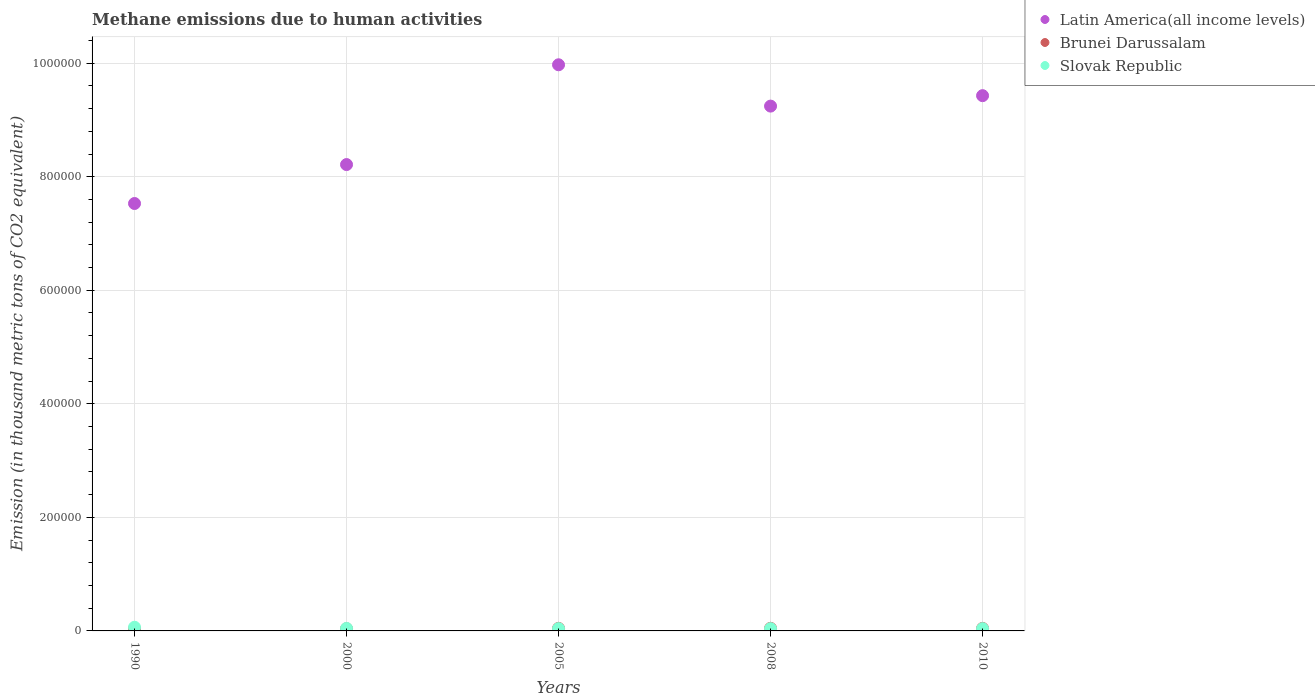How many different coloured dotlines are there?
Your response must be concise. 3. What is the amount of methane emitted in Brunei Darussalam in 2010?
Your response must be concise. 4450.4. Across all years, what is the maximum amount of methane emitted in Latin America(all income levels)?
Provide a short and direct response. 9.97e+05. Across all years, what is the minimum amount of methane emitted in Slovak Republic?
Your answer should be very brief. 3984.7. In which year was the amount of methane emitted in Brunei Darussalam maximum?
Ensure brevity in your answer.  2008. In which year was the amount of methane emitted in Brunei Darussalam minimum?
Give a very brief answer. 1990. What is the total amount of methane emitted in Slovak Republic in the graph?
Your answer should be very brief. 2.29e+04. What is the difference between the amount of methane emitted in Brunei Darussalam in 2005 and that in 2010?
Provide a succinct answer. 92.9. What is the difference between the amount of methane emitted in Latin America(all income levels) in 2000 and the amount of methane emitted in Brunei Darussalam in 2010?
Provide a short and direct response. 8.17e+05. What is the average amount of methane emitted in Brunei Darussalam per year?
Make the answer very short. 4212.1. In the year 2010, what is the difference between the amount of methane emitted in Brunei Darussalam and amount of methane emitted in Slovak Republic?
Offer a terse response. 465.7. In how many years, is the amount of methane emitted in Latin America(all income levels) greater than 720000 thousand metric tons?
Your answer should be compact. 5. What is the ratio of the amount of methane emitted in Brunei Darussalam in 2005 to that in 2008?
Make the answer very short. 0.98. Is the amount of methane emitted in Brunei Darussalam in 1990 less than that in 2010?
Your response must be concise. Yes. What is the difference between the highest and the second highest amount of methane emitted in Slovak Republic?
Ensure brevity in your answer.  2019.1. What is the difference between the highest and the lowest amount of methane emitted in Slovak Republic?
Your answer should be very brief. 2466.7. In how many years, is the amount of methane emitted in Slovak Republic greater than the average amount of methane emitted in Slovak Republic taken over all years?
Offer a terse response. 1. Is the amount of methane emitted in Slovak Republic strictly greater than the amount of methane emitted in Brunei Darussalam over the years?
Provide a short and direct response. No. Is the amount of methane emitted in Brunei Darussalam strictly less than the amount of methane emitted in Slovak Republic over the years?
Provide a succinct answer. No. How many dotlines are there?
Ensure brevity in your answer.  3. What is the difference between two consecutive major ticks on the Y-axis?
Give a very brief answer. 2.00e+05. Where does the legend appear in the graph?
Your answer should be compact. Top right. How many legend labels are there?
Make the answer very short. 3. How are the legend labels stacked?
Make the answer very short. Vertical. What is the title of the graph?
Make the answer very short. Methane emissions due to human activities. Does "Azerbaijan" appear as one of the legend labels in the graph?
Provide a short and direct response. No. What is the label or title of the X-axis?
Provide a short and direct response. Years. What is the label or title of the Y-axis?
Your answer should be very brief. Emission (in thousand metric tons of CO2 equivalent). What is the Emission (in thousand metric tons of CO2 equivalent) of Latin America(all income levels) in 1990?
Ensure brevity in your answer.  7.53e+05. What is the Emission (in thousand metric tons of CO2 equivalent) in Brunei Darussalam in 1990?
Offer a very short reply. 3591.9. What is the Emission (in thousand metric tons of CO2 equivalent) in Slovak Republic in 1990?
Offer a very short reply. 6451.4. What is the Emission (in thousand metric tons of CO2 equivalent) in Latin America(all income levels) in 2000?
Provide a succinct answer. 8.21e+05. What is the Emission (in thousand metric tons of CO2 equivalent) of Brunei Darussalam in 2000?
Keep it short and to the point. 3857.8. What is the Emission (in thousand metric tons of CO2 equivalent) of Slovak Republic in 2000?
Your answer should be compact. 4432.3. What is the Emission (in thousand metric tons of CO2 equivalent) of Latin America(all income levels) in 2005?
Ensure brevity in your answer.  9.97e+05. What is the Emission (in thousand metric tons of CO2 equivalent) in Brunei Darussalam in 2005?
Make the answer very short. 4543.3. What is the Emission (in thousand metric tons of CO2 equivalent) in Slovak Republic in 2005?
Provide a succinct answer. 4063.5. What is the Emission (in thousand metric tons of CO2 equivalent) in Latin America(all income levels) in 2008?
Keep it short and to the point. 9.24e+05. What is the Emission (in thousand metric tons of CO2 equivalent) in Brunei Darussalam in 2008?
Provide a short and direct response. 4617.1. What is the Emission (in thousand metric tons of CO2 equivalent) in Slovak Republic in 2008?
Your response must be concise. 4014.6. What is the Emission (in thousand metric tons of CO2 equivalent) of Latin America(all income levels) in 2010?
Your answer should be very brief. 9.43e+05. What is the Emission (in thousand metric tons of CO2 equivalent) in Brunei Darussalam in 2010?
Give a very brief answer. 4450.4. What is the Emission (in thousand metric tons of CO2 equivalent) of Slovak Republic in 2010?
Your response must be concise. 3984.7. Across all years, what is the maximum Emission (in thousand metric tons of CO2 equivalent) of Latin America(all income levels)?
Offer a very short reply. 9.97e+05. Across all years, what is the maximum Emission (in thousand metric tons of CO2 equivalent) of Brunei Darussalam?
Your answer should be very brief. 4617.1. Across all years, what is the maximum Emission (in thousand metric tons of CO2 equivalent) in Slovak Republic?
Give a very brief answer. 6451.4. Across all years, what is the minimum Emission (in thousand metric tons of CO2 equivalent) in Latin America(all income levels)?
Give a very brief answer. 7.53e+05. Across all years, what is the minimum Emission (in thousand metric tons of CO2 equivalent) of Brunei Darussalam?
Make the answer very short. 3591.9. Across all years, what is the minimum Emission (in thousand metric tons of CO2 equivalent) of Slovak Republic?
Provide a short and direct response. 3984.7. What is the total Emission (in thousand metric tons of CO2 equivalent) in Latin America(all income levels) in the graph?
Ensure brevity in your answer.  4.44e+06. What is the total Emission (in thousand metric tons of CO2 equivalent) of Brunei Darussalam in the graph?
Offer a very short reply. 2.11e+04. What is the total Emission (in thousand metric tons of CO2 equivalent) in Slovak Republic in the graph?
Keep it short and to the point. 2.29e+04. What is the difference between the Emission (in thousand metric tons of CO2 equivalent) in Latin America(all income levels) in 1990 and that in 2000?
Your response must be concise. -6.86e+04. What is the difference between the Emission (in thousand metric tons of CO2 equivalent) of Brunei Darussalam in 1990 and that in 2000?
Give a very brief answer. -265.9. What is the difference between the Emission (in thousand metric tons of CO2 equivalent) in Slovak Republic in 1990 and that in 2000?
Give a very brief answer. 2019.1. What is the difference between the Emission (in thousand metric tons of CO2 equivalent) of Latin America(all income levels) in 1990 and that in 2005?
Keep it short and to the point. -2.44e+05. What is the difference between the Emission (in thousand metric tons of CO2 equivalent) in Brunei Darussalam in 1990 and that in 2005?
Make the answer very short. -951.4. What is the difference between the Emission (in thousand metric tons of CO2 equivalent) in Slovak Republic in 1990 and that in 2005?
Offer a terse response. 2387.9. What is the difference between the Emission (in thousand metric tons of CO2 equivalent) in Latin America(all income levels) in 1990 and that in 2008?
Offer a terse response. -1.72e+05. What is the difference between the Emission (in thousand metric tons of CO2 equivalent) of Brunei Darussalam in 1990 and that in 2008?
Make the answer very short. -1025.2. What is the difference between the Emission (in thousand metric tons of CO2 equivalent) in Slovak Republic in 1990 and that in 2008?
Offer a terse response. 2436.8. What is the difference between the Emission (in thousand metric tons of CO2 equivalent) of Latin America(all income levels) in 1990 and that in 2010?
Keep it short and to the point. -1.90e+05. What is the difference between the Emission (in thousand metric tons of CO2 equivalent) in Brunei Darussalam in 1990 and that in 2010?
Keep it short and to the point. -858.5. What is the difference between the Emission (in thousand metric tons of CO2 equivalent) in Slovak Republic in 1990 and that in 2010?
Ensure brevity in your answer.  2466.7. What is the difference between the Emission (in thousand metric tons of CO2 equivalent) in Latin America(all income levels) in 2000 and that in 2005?
Ensure brevity in your answer.  -1.76e+05. What is the difference between the Emission (in thousand metric tons of CO2 equivalent) in Brunei Darussalam in 2000 and that in 2005?
Your answer should be compact. -685.5. What is the difference between the Emission (in thousand metric tons of CO2 equivalent) in Slovak Republic in 2000 and that in 2005?
Provide a short and direct response. 368.8. What is the difference between the Emission (in thousand metric tons of CO2 equivalent) of Latin America(all income levels) in 2000 and that in 2008?
Keep it short and to the point. -1.03e+05. What is the difference between the Emission (in thousand metric tons of CO2 equivalent) in Brunei Darussalam in 2000 and that in 2008?
Provide a succinct answer. -759.3. What is the difference between the Emission (in thousand metric tons of CO2 equivalent) in Slovak Republic in 2000 and that in 2008?
Ensure brevity in your answer.  417.7. What is the difference between the Emission (in thousand metric tons of CO2 equivalent) of Latin America(all income levels) in 2000 and that in 2010?
Give a very brief answer. -1.21e+05. What is the difference between the Emission (in thousand metric tons of CO2 equivalent) in Brunei Darussalam in 2000 and that in 2010?
Keep it short and to the point. -592.6. What is the difference between the Emission (in thousand metric tons of CO2 equivalent) in Slovak Republic in 2000 and that in 2010?
Ensure brevity in your answer.  447.6. What is the difference between the Emission (in thousand metric tons of CO2 equivalent) in Latin America(all income levels) in 2005 and that in 2008?
Provide a short and direct response. 7.28e+04. What is the difference between the Emission (in thousand metric tons of CO2 equivalent) of Brunei Darussalam in 2005 and that in 2008?
Your answer should be compact. -73.8. What is the difference between the Emission (in thousand metric tons of CO2 equivalent) of Slovak Republic in 2005 and that in 2008?
Provide a short and direct response. 48.9. What is the difference between the Emission (in thousand metric tons of CO2 equivalent) of Latin America(all income levels) in 2005 and that in 2010?
Give a very brief answer. 5.44e+04. What is the difference between the Emission (in thousand metric tons of CO2 equivalent) in Brunei Darussalam in 2005 and that in 2010?
Keep it short and to the point. 92.9. What is the difference between the Emission (in thousand metric tons of CO2 equivalent) of Slovak Republic in 2005 and that in 2010?
Your answer should be compact. 78.8. What is the difference between the Emission (in thousand metric tons of CO2 equivalent) of Latin America(all income levels) in 2008 and that in 2010?
Make the answer very short. -1.84e+04. What is the difference between the Emission (in thousand metric tons of CO2 equivalent) of Brunei Darussalam in 2008 and that in 2010?
Give a very brief answer. 166.7. What is the difference between the Emission (in thousand metric tons of CO2 equivalent) in Slovak Republic in 2008 and that in 2010?
Offer a very short reply. 29.9. What is the difference between the Emission (in thousand metric tons of CO2 equivalent) in Latin America(all income levels) in 1990 and the Emission (in thousand metric tons of CO2 equivalent) in Brunei Darussalam in 2000?
Offer a very short reply. 7.49e+05. What is the difference between the Emission (in thousand metric tons of CO2 equivalent) in Latin America(all income levels) in 1990 and the Emission (in thousand metric tons of CO2 equivalent) in Slovak Republic in 2000?
Provide a succinct answer. 7.48e+05. What is the difference between the Emission (in thousand metric tons of CO2 equivalent) in Brunei Darussalam in 1990 and the Emission (in thousand metric tons of CO2 equivalent) in Slovak Republic in 2000?
Keep it short and to the point. -840.4. What is the difference between the Emission (in thousand metric tons of CO2 equivalent) of Latin America(all income levels) in 1990 and the Emission (in thousand metric tons of CO2 equivalent) of Brunei Darussalam in 2005?
Offer a terse response. 7.48e+05. What is the difference between the Emission (in thousand metric tons of CO2 equivalent) in Latin America(all income levels) in 1990 and the Emission (in thousand metric tons of CO2 equivalent) in Slovak Republic in 2005?
Offer a very short reply. 7.49e+05. What is the difference between the Emission (in thousand metric tons of CO2 equivalent) in Brunei Darussalam in 1990 and the Emission (in thousand metric tons of CO2 equivalent) in Slovak Republic in 2005?
Give a very brief answer. -471.6. What is the difference between the Emission (in thousand metric tons of CO2 equivalent) in Latin America(all income levels) in 1990 and the Emission (in thousand metric tons of CO2 equivalent) in Brunei Darussalam in 2008?
Your answer should be compact. 7.48e+05. What is the difference between the Emission (in thousand metric tons of CO2 equivalent) of Latin America(all income levels) in 1990 and the Emission (in thousand metric tons of CO2 equivalent) of Slovak Republic in 2008?
Offer a terse response. 7.49e+05. What is the difference between the Emission (in thousand metric tons of CO2 equivalent) of Brunei Darussalam in 1990 and the Emission (in thousand metric tons of CO2 equivalent) of Slovak Republic in 2008?
Ensure brevity in your answer.  -422.7. What is the difference between the Emission (in thousand metric tons of CO2 equivalent) of Latin America(all income levels) in 1990 and the Emission (in thousand metric tons of CO2 equivalent) of Brunei Darussalam in 2010?
Make the answer very short. 7.48e+05. What is the difference between the Emission (in thousand metric tons of CO2 equivalent) of Latin America(all income levels) in 1990 and the Emission (in thousand metric tons of CO2 equivalent) of Slovak Republic in 2010?
Your response must be concise. 7.49e+05. What is the difference between the Emission (in thousand metric tons of CO2 equivalent) in Brunei Darussalam in 1990 and the Emission (in thousand metric tons of CO2 equivalent) in Slovak Republic in 2010?
Give a very brief answer. -392.8. What is the difference between the Emission (in thousand metric tons of CO2 equivalent) of Latin America(all income levels) in 2000 and the Emission (in thousand metric tons of CO2 equivalent) of Brunei Darussalam in 2005?
Offer a terse response. 8.17e+05. What is the difference between the Emission (in thousand metric tons of CO2 equivalent) in Latin America(all income levels) in 2000 and the Emission (in thousand metric tons of CO2 equivalent) in Slovak Republic in 2005?
Provide a succinct answer. 8.17e+05. What is the difference between the Emission (in thousand metric tons of CO2 equivalent) of Brunei Darussalam in 2000 and the Emission (in thousand metric tons of CO2 equivalent) of Slovak Republic in 2005?
Your response must be concise. -205.7. What is the difference between the Emission (in thousand metric tons of CO2 equivalent) in Latin America(all income levels) in 2000 and the Emission (in thousand metric tons of CO2 equivalent) in Brunei Darussalam in 2008?
Offer a terse response. 8.17e+05. What is the difference between the Emission (in thousand metric tons of CO2 equivalent) of Latin America(all income levels) in 2000 and the Emission (in thousand metric tons of CO2 equivalent) of Slovak Republic in 2008?
Provide a short and direct response. 8.17e+05. What is the difference between the Emission (in thousand metric tons of CO2 equivalent) of Brunei Darussalam in 2000 and the Emission (in thousand metric tons of CO2 equivalent) of Slovak Republic in 2008?
Provide a short and direct response. -156.8. What is the difference between the Emission (in thousand metric tons of CO2 equivalent) of Latin America(all income levels) in 2000 and the Emission (in thousand metric tons of CO2 equivalent) of Brunei Darussalam in 2010?
Give a very brief answer. 8.17e+05. What is the difference between the Emission (in thousand metric tons of CO2 equivalent) of Latin America(all income levels) in 2000 and the Emission (in thousand metric tons of CO2 equivalent) of Slovak Republic in 2010?
Offer a terse response. 8.17e+05. What is the difference between the Emission (in thousand metric tons of CO2 equivalent) in Brunei Darussalam in 2000 and the Emission (in thousand metric tons of CO2 equivalent) in Slovak Republic in 2010?
Provide a succinct answer. -126.9. What is the difference between the Emission (in thousand metric tons of CO2 equivalent) in Latin America(all income levels) in 2005 and the Emission (in thousand metric tons of CO2 equivalent) in Brunei Darussalam in 2008?
Your response must be concise. 9.93e+05. What is the difference between the Emission (in thousand metric tons of CO2 equivalent) in Latin America(all income levels) in 2005 and the Emission (in thousand metric tons of CO2 equivalent) in Slovak Republic in 2008?
Your answer should be very brief. 9.93e+05. What is the difference between the Emission (in thousand metric tons of CO2 equivalent) of Brunei Darussalam in 2005 and the Emission (in thousand metric tons of CO2 equivalent) of Slovak Republic in 2008?
Keep it short and to the point. 528.7. What is the difference between the Emission (in thousand metric tons of CO2 equivalent) in Latin America(all income levels) in 2005 and the Emission (in thousand metric tons of CO2 equivalent) in Brunei Darussalam in 2010?
Provide a succinct answer. 9.93e+05. What is the difference between the Emission (in thousand metric tons of CO2 equivalent) in Latin America(all income levels) in 2005 and the Emission (in thousand metric tons of CO2 equivalent) in Slovak Republic in 2010?
Give a very brief answer. 9.93e+05. What is the difference between the Emission (in thousand metric tons of CO2 equivalent) of Brunei Darussalam in 2005 and the Emission (in thousand metric tons of CO2 equivalent) of Slovak Republic in 2010?
Make the answer very short. 558.6. What is the difference between the Emission (in thousand metric tons of CO2 equivalent) of Latin America(all income levels) in 2008 and the Emission (in thousand metric tons of CO2 equivalent) of Brunei Darussalam in 2010?
Keep it short and to the point. 9.20e+05. What is the difference between the Emission (in thousand metric tons of CO2 equivalent) in Latin America(all income levels) in 2008 and the Emission (in thousand metric tons of CO2 equivalent) in Slovak Republic in 2010?
Ensure brevity in your answer.  9.20e+05. What is the difference between the Emission (in thousand metric tons of CO2 equivalent) in Brunei Darussalam in 2008 and the Emission (in thousand metric tons of CO2 equivalent) in Slovak Republic in 2010?
Make the answer very short. 632.4. What is the average Emission (in thousand metric tons of CO2 equivalent) in Latin America(all income levels) per year?
Ensure brevity in your answer.  8.88e+05. What is the average Emission (in thousand metric tons of CO2 equivalent) of Brunei Darussalam per year?
Ensure brevity in your answer.  4212.1. What is the average Emission (in thousand metric tons of CO2 equivalent) in Slovak Republic per year?
Keep it short and to the point. 4589.3. In the year 1990, what is the difference between the Emission (in thousand metric tons of CO2 equivalent) of Latin America(all income levels) and Emission (in thousand metric tons of CO2 equivalent) of Brunei Darussalam?
Ensure brevity in your answer.  7.49e+05. In the year 1990, what is the difference between the Emission (in thousand metric tons of CO2 equivalent) in Latin America(all income levels) and Emission (in thousand metric tons of CO2 equivalent) in Slovak Republic?
Provide a short and direct response. 7.46e+05. In the year 1990, what is the difference between the Emission (in thousand metric tons of CO2 equivalent) of Brunei Darussalam and Emission (in thousand metric tons of CO2 equivalent) of Slovak Republic?
Provide a succinct answer. -2859.5. In the year 2000, what is the difference between the Emission (in thousand metric tons of CO2 equivalent) in Latin America(all income levels) and Emission (in thousand metric tons of CO2 equivalent) in Brunei Darussalam?
Offer a terse response. 8.18e+05. In the year 2000, what is the difference between the Emission (in thousand metric tons of CO2 equivalent) in Latin America(all income levels) and Emission (in thousand metric tons of CO2 equivalent) in Slovak Republic?
Offer a very short reply. 8.17e+05. In the year 2000, what is the difference between the Emission (in thousand metric tons of CO2 equivalent) of Brunei Darussalam and Emission (in thousand metric tons of CO2 equivalent) of Slovak Republic?
Your answer should be compact. -574.5. In the year 2005, what is the difference between the Emission (in thousand metric tons of CO2 equivalent) of Latin America(all income levels) and Emission (in thousand metric tons of CO2 equivalent) of Brunei Darussalam?
Keep it short and to the point. 9.93e+05. In the year 2005, what is the difference between the Emission (in thousand metric tons of CO2 equivalent) in Latin America(all income levels) and Emission (in thousand metric tons of CO2 equivalent) in Slovak Republic?
Provide a succinct answer. 9.93e+05. In the year 2005, what is the difference between the Emission (in thousand metric tons of CO2 equivalent) of Brunei Darussalam and Emission (in thousand metric tons of CO2 equivalent) of Slovak Republic?
Ensure brevity in your answer.  479.8. In the year 2008, what is the difference between the Emission (in thousand metric tons of CO2 equivalent) of Latin America(all income levels) and Emission (in thousand metric tons of CO2 equivalent) of Brunei Darussalam?
Ensure brevity in your answer.  9.20e+05. In the year 2008, what is the difference between the Emission (in thousand metric tons of CO2 equivalent) of Latin America(all income levels) and Emission (in thousand metric tons of CO2 equivalent) of Slovak Republic?
Your response must be concise. 9.20e+05. In the year 2008, what is the difference between the Emission (in thousand metric tons of CO2 equivalent) of Brunei Darussalam and Emission (in thousand metric tons of CO2 equivalent) of Slovak Republic?
Your answer should be very brief. 602.5. In the year 2010, what is the difference between the Emission (in thousand metric tons of CO2 equivalent) of Latin America(all income levels) and Emission (in thousand metric tons of CO2 equivalent) of Brunei Darussalam?
Your response must be concise. 9.38e+05. In the year 2010, what is the difference between the Emission (in thousand metric tons of CO2 equivalent) in Latin America(all income levels) and Emission (in thousand metric tons of CO2 equivalent) in Slovak Republic?
Ensure brevity in your answer.  9.39e+05. In the year 2010, what is the difference between the Emission (in thousand metric tons of CO2 equivalent) of Brunei Darussalam and Emission (in thousand metric tons of CO2 equivalent) of Slovak Republic?
Your response must be concise. 465.7. What is the ratio of the Emission (in thousand metric tons of CO2 equivalent) in Latin America(all income levels) in 1990 to that in 2000?
Give a very brief answer. 0.92. What is the ratio of the Emission (in thousand metric tons of CO2 equivalent) in Brunei Darussalam in 1990 to that in 2000?
Offer a terse response. 0.93. What is the ratio of the Emission (in thousand metric tons of CO2 equivalent) of Slovak Republic in 1990 to that in 2000?
Offer a very short reply. 1.46. What is the ratio of the Emission (in thousand metric tons of CO2 equivalent) of Latin America(all income levels) in 1990 to that in 2005?
Your response must be concise. 0.76. What is the ratio of the Emission (in thousand metric tons of CO2 equivalent) of Brunei Darussalam in 1990 to that in 2005?
Your answer should be very brief. 0.79. What is the ratio of the Emission (in thousand metric tons of CO2 equivalent) of Slovak Republic in 1990 to that in 2005?
Your answer should be compact. 1.59. What is the ratio of the Emission (in thousand metric tons of CO2 equivalent) of Latin America(all income levels) in 1990 to that in 2008?
Offer a terse response. 0.81. What is the ratio of the Emission (in thousand metric tons of CO2 equivalent) in Brunei Darussalam in 1990 to that in 2008?
Keep it short and to the point. 0.78. What is the ratio of the Emission (in thousand metric tons of CO2 equivalent) in Slovak Republic in 1990 to that in 2008?
Ensure brevity in your answer.  1.61. What is the ratio of the Emission (in thousand metric tons of CO2 equivalent) in Latin America(all income levels) in 1990 to that in 2010?
Your answer should be compact. 0.8. What is the ratio of the Emission (in thousand metric tons of CO2 equivalent) of Brunei Darussalam in 1990 to that in 2010?
Give a very brief answer. 0.81. What is the ratio of the Emission (in thousand metric tons of CO2 equivalent) in Slovak Republic in 1990 to that in 2010?
Ensure brevity in your answer.  1.62. What is the ratio of the Emission (in thousand metric tons of CO2 equivalent) in Latin America(all income levels) in 2000 to that in 2005?
Offer a terse response. 0.82. What is the ratio of the Emission (in thousand metric tons of CO2 equivalent) of Brunei Darussalam in 2000 to that in 2005?
Provide a succinct answer. 0.85. What is the ratio of the Emission (in thousand metric tons of CO2 equivalent) in Slovak Republic in 2000 to that in 2005?
Give a very brief answer. 1.09. What is the ratio of the Emission (in thousand metric tons of CO2 equivalent) in Latin America(all income levels) in 2000 to that in 2008?
Ensure brevity in your answer.  0.89. What is the ratio of the Emission (in thousand metric tons of CO2 equivalent) of Brunei Darussalam in 2000 to that in 2008?
Make the answer very short. 0.84. What is the ratio of the Emission (in thousand metric tons of CO2 equivalent) of Slovak Republic in 2000 to that in 2008?
Give a very brief answer. 1.1. What is the ratio of the Emission (in thousand metric tons of CO2 equivalent) of Latin America(all income levels) in 2000 to that in 2010?
Provide a succinct answer. 0.87. What is the ratio of the Emission (in thousand metric tons of CO2 equivalent) in Brunei Darussalam in 2000 to that in 2010?
Your response must be concise. 0.87. What is the ratio of the Emission (in thousand metric tons of CO2 equivalent) of Slovak Republic in 2000 to that in 2010?
Give a very brief answer. 1.11. What is the ratio of the Emission (in thousand metric tons of CO2 equivalent) in Latin America(all income levels) in 2005 to that in 2008?
Offer a terse response. 1.08. What is the ratio of the Emission (in thousand metric tons of CO2 equivalent) of Brunei Darussalam in 2005 to that in 2008?
Provide a succinct answer. 0.98. What is the ratio of the Emission (in thousand metric tons of CO2 equivalent) in Slovak Republic in 2005 to that in 2008?
Offer a terse response. 1.01. What is the ratio of the Emission (in thousand metric tons of CO2 equivalent) of Latin America(all income levels) in 2005 to that in 2010?
Your answer should be very brief. 1.06. What is the ratio of the Emission (in thousand metric tons of CO2 equivalent) of Brunei Darussalam in 2005 to that in 2010?
Your response must be concise. 1.02. What is the ratio of the Emission (in thousand metric tons of CO2 equivalent) in Slovak Republic in 2005 to that in 2010?
Give a very brief answer. 1.02. What is the ratio of the Emission (in thousand metric tons of CO2 equivalent) of Latin America(all income levels) in 2008 to that in 2010?
Your answer should be compact. 0.98. What is the ratio of the Emission (in thousand metric tons of CO2 equivalent) in Brunei Darussalam in 2008 to that in 2010?
Offer a terse response. 1.04. What is the ratio of the Emission (in thousand metric tons of CO2 equivalent) of Slovak Republic in 2008 to that in 2010?
Your answer should be compact. 1.01. What is the difference between the highest and the second highest Emission (in thousand metric tons of CO2 equivalent) of Latin America(all income levels)?
Provide a succinct answer. 5.44e+04. What is the difference between the highest and the second highest Emission (in thousand metric tons of CO2 equivalent) of Brunei Darussalam?
Your answer should be very brief. 73.8. What is the difference between the highest and the second highest Emission (in thousand metric tons of CO2 equivalent) in Slovak Republic?
Offer a very short reply. 2019.1. What is the difference between the highest and the lowest Emission (in thousand metric tons of CO2 equivalent) of Latin America(all income levels)?
Give a very brief answer. 2.44e+05. What is the difference between the highest and the lowest Emission (in thousand metric tons of CO2 equivalent) of Brunei Darussalam?
Provide a succinct answer. 1025.2. What is the difference between the highest and the lowest Emission (in thousand metric tons of CO2 equivalent) of Slovak Republic?
Your response must be concise. 2466.7. 